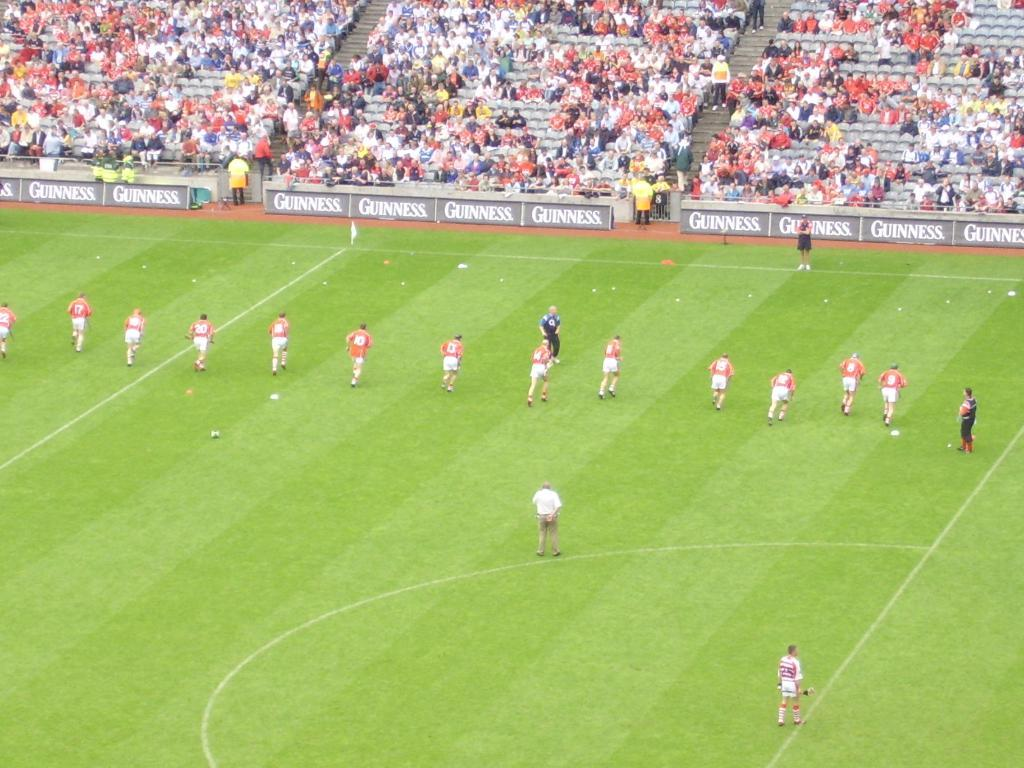Provide a one-sentence caption for the provided image. Many Guinness signs line the edges of this large soccer field. 